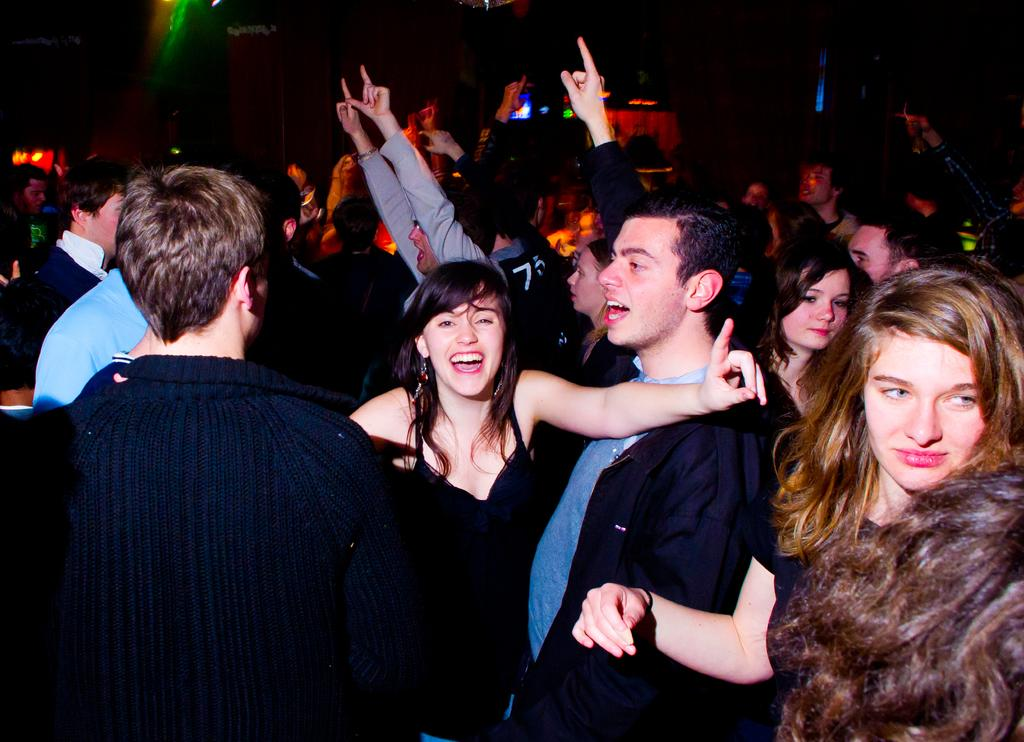How many people are in the image? There are many people in the image. What are the people in the image doing? The people are dancing on the floor. Can you describe the setting where the people are dancing? The setting appears to be a pub or similar social establishment. What type of page can be seen being turned in the image? There is no page present in the image; it features people dancing in a social establishment. What type of rake is being used by one of the dancers in the image? There is no rake present in the image; it features people dancing in a social establishment. 